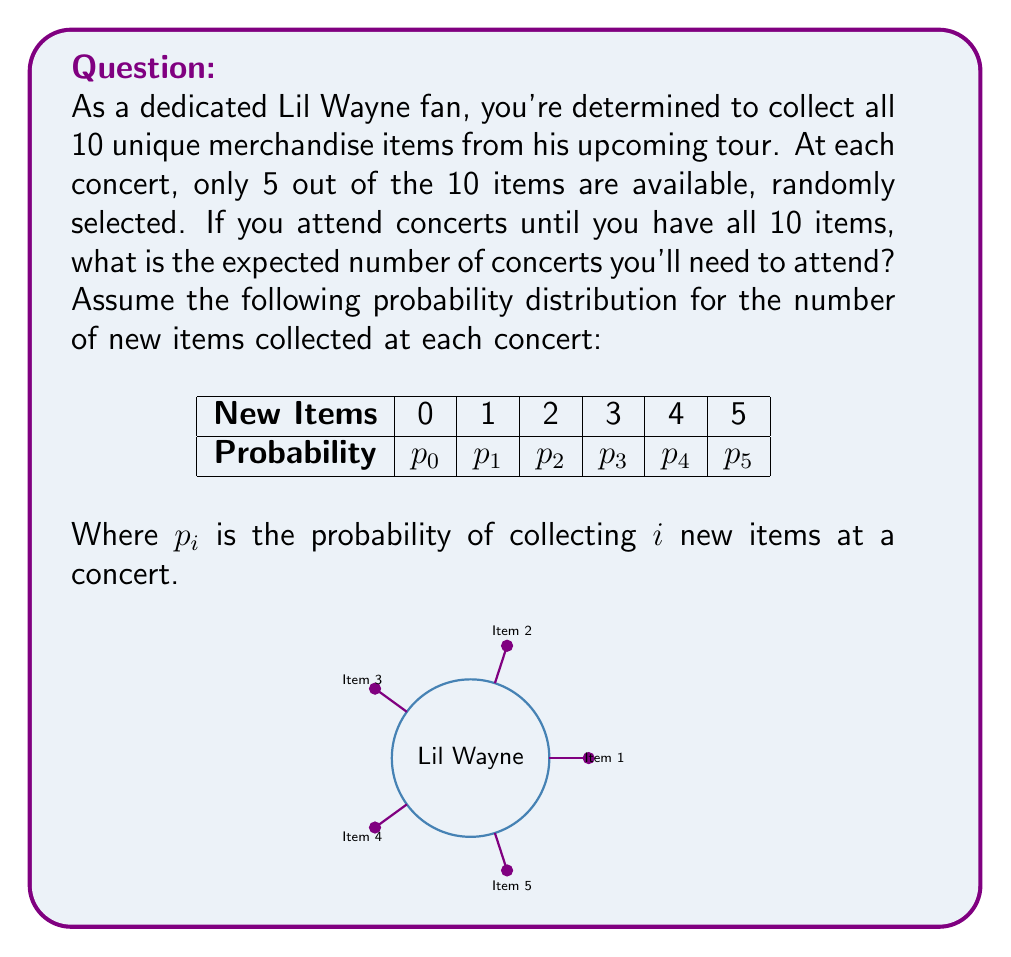Give your solution to this math problem. To solve this problem, we'll use the concept of expected value and the Coupon Collector's Problem.

1) First, let's calculate the probabilities $p_i$:

   $p_0 = \frac{\binom{5}{5}}{\binom{10}{5}} = \frac{1}{252}$
   $p_1 = \frac{\binom{5}{4}\binom{5}{1}}{\binom{10}{5}} = \frac{25}{252}$
   $p_2 = \frac{\binom{5}{3}\binom{5}{2}}{\binom{10}{5}} = \frac{100}{252}$
   $p_3 = \frac{\binom{5}{2}\binom{5}{3}}{\binom{10}{5}} = \frac{100}{252}$
   $p_4 = \frac{\binom{5}{1}\binom{5}{4}}{\binom{10}{5}} = \frac{25}{252}$
   $p_5 = \frac{\binom{5}{0}\binom{5}{5}}{\binom{10}{5}} = \frac{1}{252}$

2) The expected number of new items collected at each concert is:

   $E[X] = 0p_0 + 1p_1 + 2p_2 + 3p_3 + 4p_4 + 5p_5 = \frac{5}{2}$

3) Now, we can use the Coupon Collector's Problem formula. The expected number of concerts needed to collect all 10 items is:

   $E[N] = 10 \cdot (\frac{1}{10} + \frac{1}{9} + \frac{1}{8} + ... + \frac{1}{1})$

4) However, since we collect an average of 2.5 items per concert, we need to divide this by 2.5:

   $E[N] = \frac{10}{2.5} \cdot (\frac{1}{10} + \frac{1}{9} + \frac{1}{8} + ... + \frac{1}{1})$

5) Calculating this:

   $E[N] = 4 \cdot (2.928968254) \approx 11.71587302$

Therefore, you can expect to attend approximately 12 concerts to collect all 10 merchandise items.
Answer: 12 concerts 